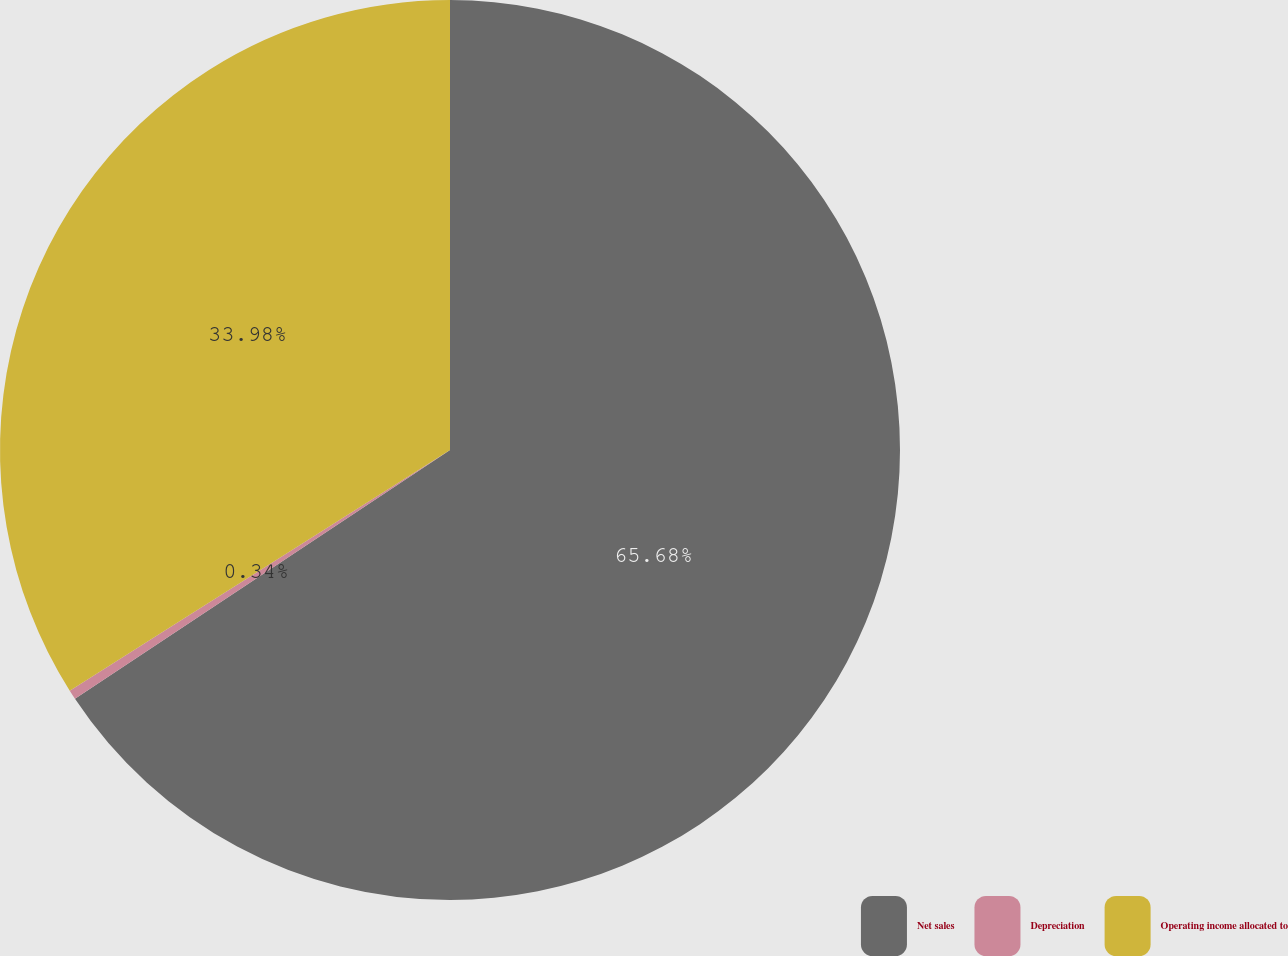<chart> <loc_0><loc_0><loc_500><loc_500><pie_chart><fcel>Net sales<fcel>Depreciation<fcel>Operating income allocated to<nl><fcel>65.68%<fcel>0.34%<fcel>33.98%<nl></chart> 